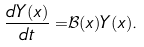<formula> <loc_0><loc_0><loc_500><loc_500>\frac { d Y ( x ) } { d t } = & \mathcal { B } ( x ) Y ( x ) .</formula> 